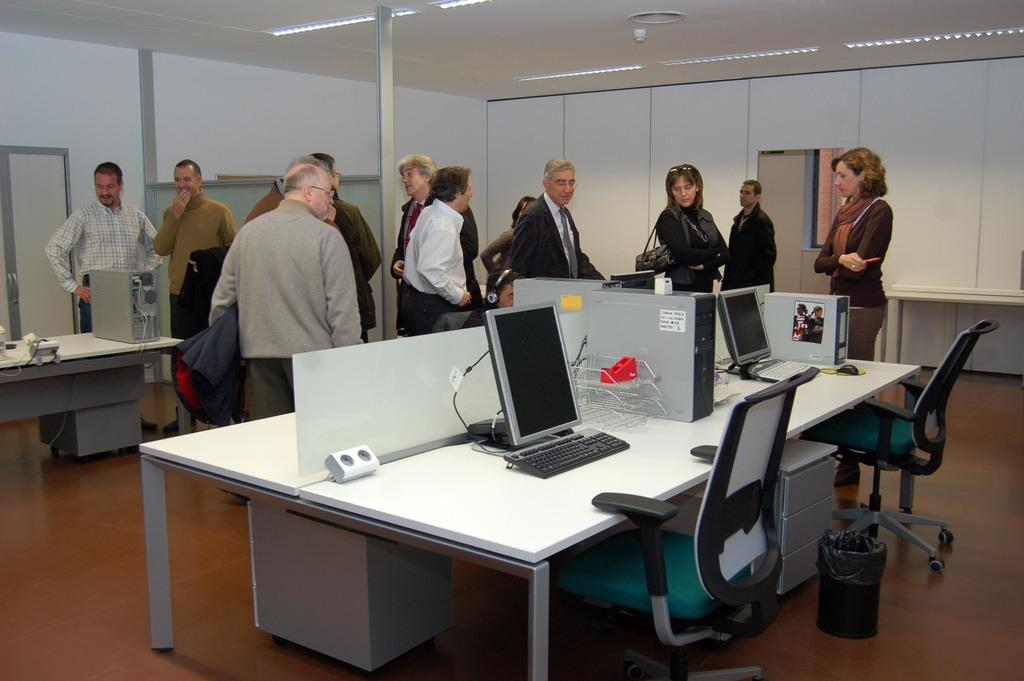How many people are in the image? There is a group of people in the image, but the exact number is not specified. What are the people doing in the image? The people are standing in the image. What is on the table in the image? There are systems on the table in the image. What type of wine is being served at the scene in the image? There is no mention of wine or a scene in the image; it only shows a group of people standing and a table with systems on it. 